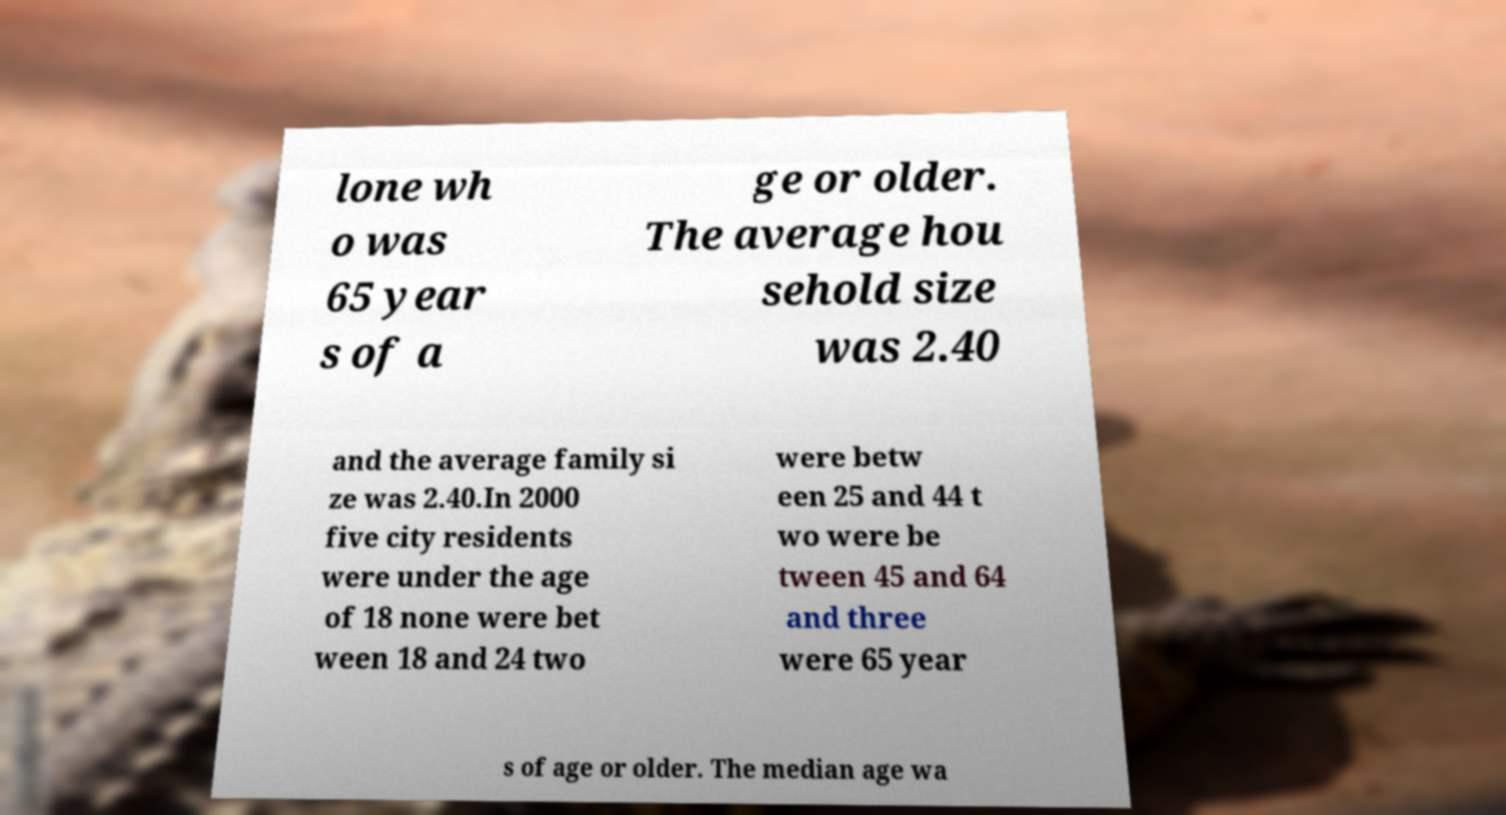Please read and relay the text visible in this image. What does it say? lone wh o was 65 year s of a ge or older. The average hou sehold size was 2.40 and the average family si ze was 2.40.In 2000 five city residents were under the age of 18 none were bet ween 18 and 24 two were betw een 25 and 44 t wo were be tween 45 and 64 and three were 65 year s of age or older. The median age wa 